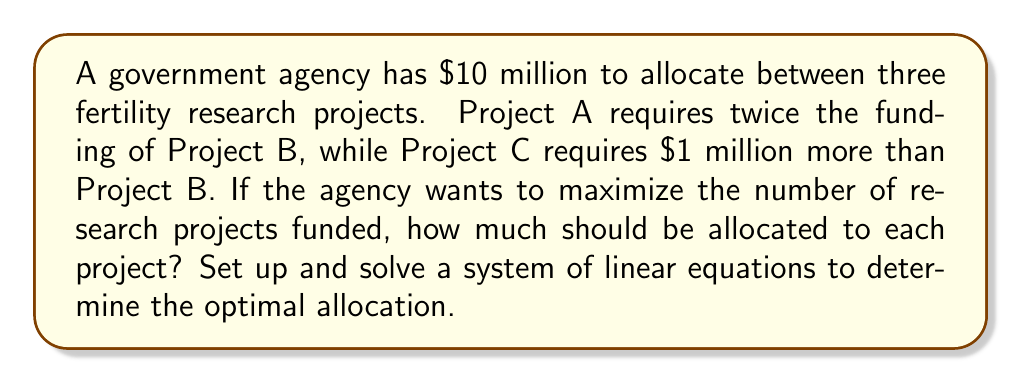Provide a solution to this math problem. Let's approach this step-by-step:

1) Define variables:
   Let $x$ = funding for Project B (in millions)
   Then, $2x$ = funding for Project A
   And, $x + 1$ = funding for Project C

2) Set up the equation based on the total budget:
   $2x + x + (x + 1) = 10$

3) Simplify the equation:
   $4x + 1 = 10$

4) Solve for $x$:
   $4x = 9$
   $x = \frac{9}{4} = 2.25$

5) Calculate funding for each project:
   Project A: $2x = 2(2.25) = 4.5$ million
   Project B: $x = 2.25$ million
   Project C: $x + 1 = 2.25 + 1 = 3.25$ million

6) Verify the total:
   $4.5 + 2.25 + 3.25 = 10$ million

Therefore, the optimal allocation to maximize the number of projects funded is:
Project A: $4.5 million
Project B: $2.25 million
Project C: $3.25 million
Answer: A: $4.5 million, B: $2.25 million, C: $3.25 million 